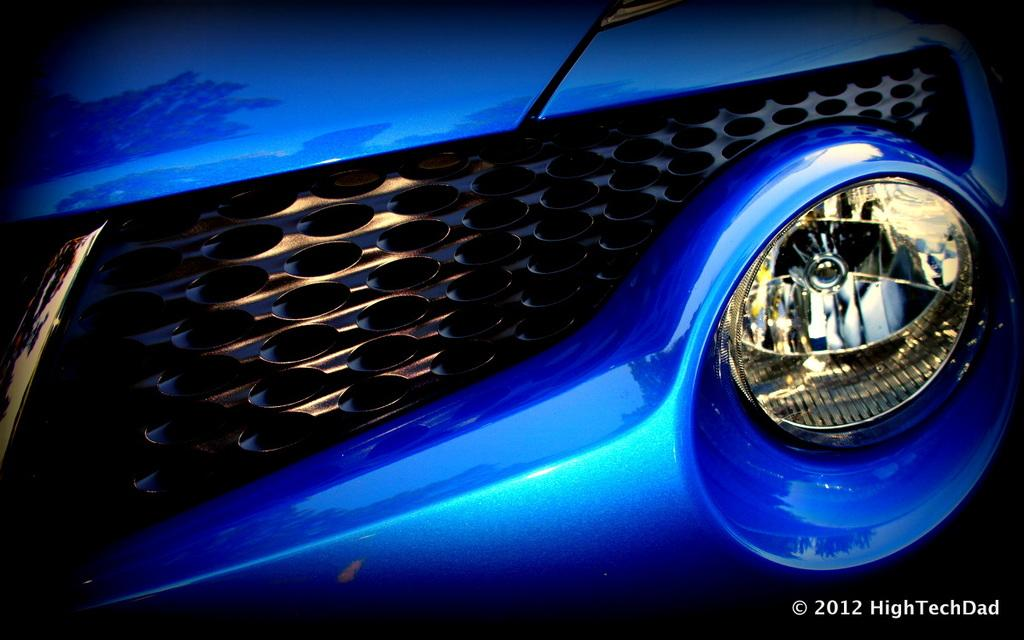What type of object is featured in the image? There is a grille and a headlight in the image, which suggests it is a vehicle. Can you describe any text present in the image? Yes, there is text in the bottom right side of the image. What additional information is provided in the text? The year is visible in the bottom right side of the image. What type of substance is being used to tell a story in the image? There is no substance or story being told in the image; it features a grille, headlight, and text with the year. 